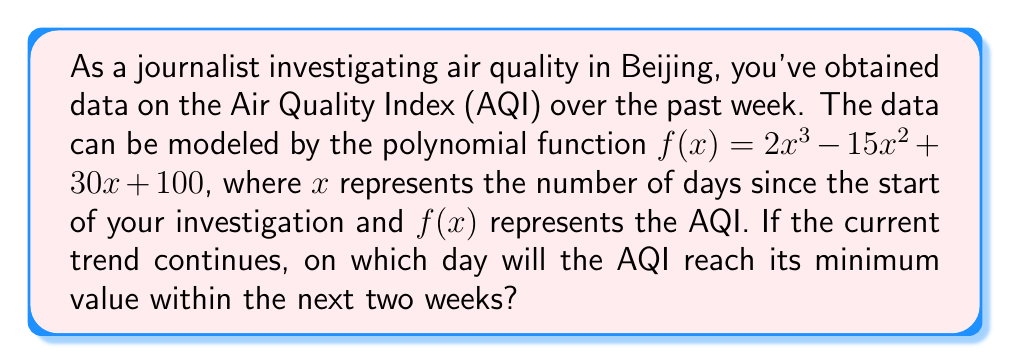Show me your answer to this math problem. To find the day when the AQI reaches its minimum value, we need to follow these steps:

1) First, we need to find the derivative of the function to determine where it reaches its minimum:
   $f'(x) = 6x^2 - 30x + 30$

2) Set the derivative equal to zero to find the critical points:
   $6x^2 - 30x + 30 = 0$

3) Solve this quadratic equation:
   $6(x^2 - 5x + 5) = 0$
   $x^2 - 5x + 5 = 0$

4) Use the quadratic formula: $x = \frac{-b \pm \sqrt{b^2 - 4ac}}{2a}$
   $x = \frac{5 \pm \sqrt{25 - 20}}{2} = \frac{5 \pm \sqrt{5}}{2}$

5) This gives us two solutions:
   $x_1 = \frac{5 + \sqrt{5}}{2} \approx 3.618$
   $x_2 = \frac{5 - \sqrt{5}}{2} \approx 1.382$

6) To determine which of these is a minimum, we can check the second derivative:
   $f''(x) = 12x - 30$

7) Evaluate $f''(x)$ at both critical points:
   $f''(3.618) > 0$ and $f''(1.382) < 0$

8) Since $f''(3.618) > 0$, this point is a local minimum.

9) The question asks for the day within the next two weeks, so we round up to the nearest whole number: 4.

Therefore, if the trend continues, the AQI will reach its minimum value on day 4 of your investigation.
Answer: Day 4 